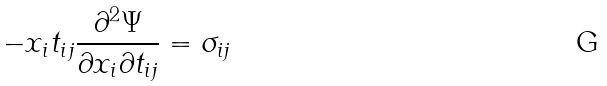<formula> <loc_0><loc_0><loc_500><loc_500>- x _ { i } t _ { i j } \frac { \partial ^ { 2 } \Psi } { \partial x _ { i } \partial t _ { i j } } = \sigma _ { i j }</formula> 